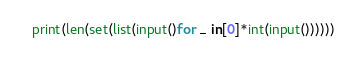<code> <loc_0><loc_0><loc_500><loc_500><_Python_>print(len(set(list(input()for _ in[0]*int(input())))))</code> 